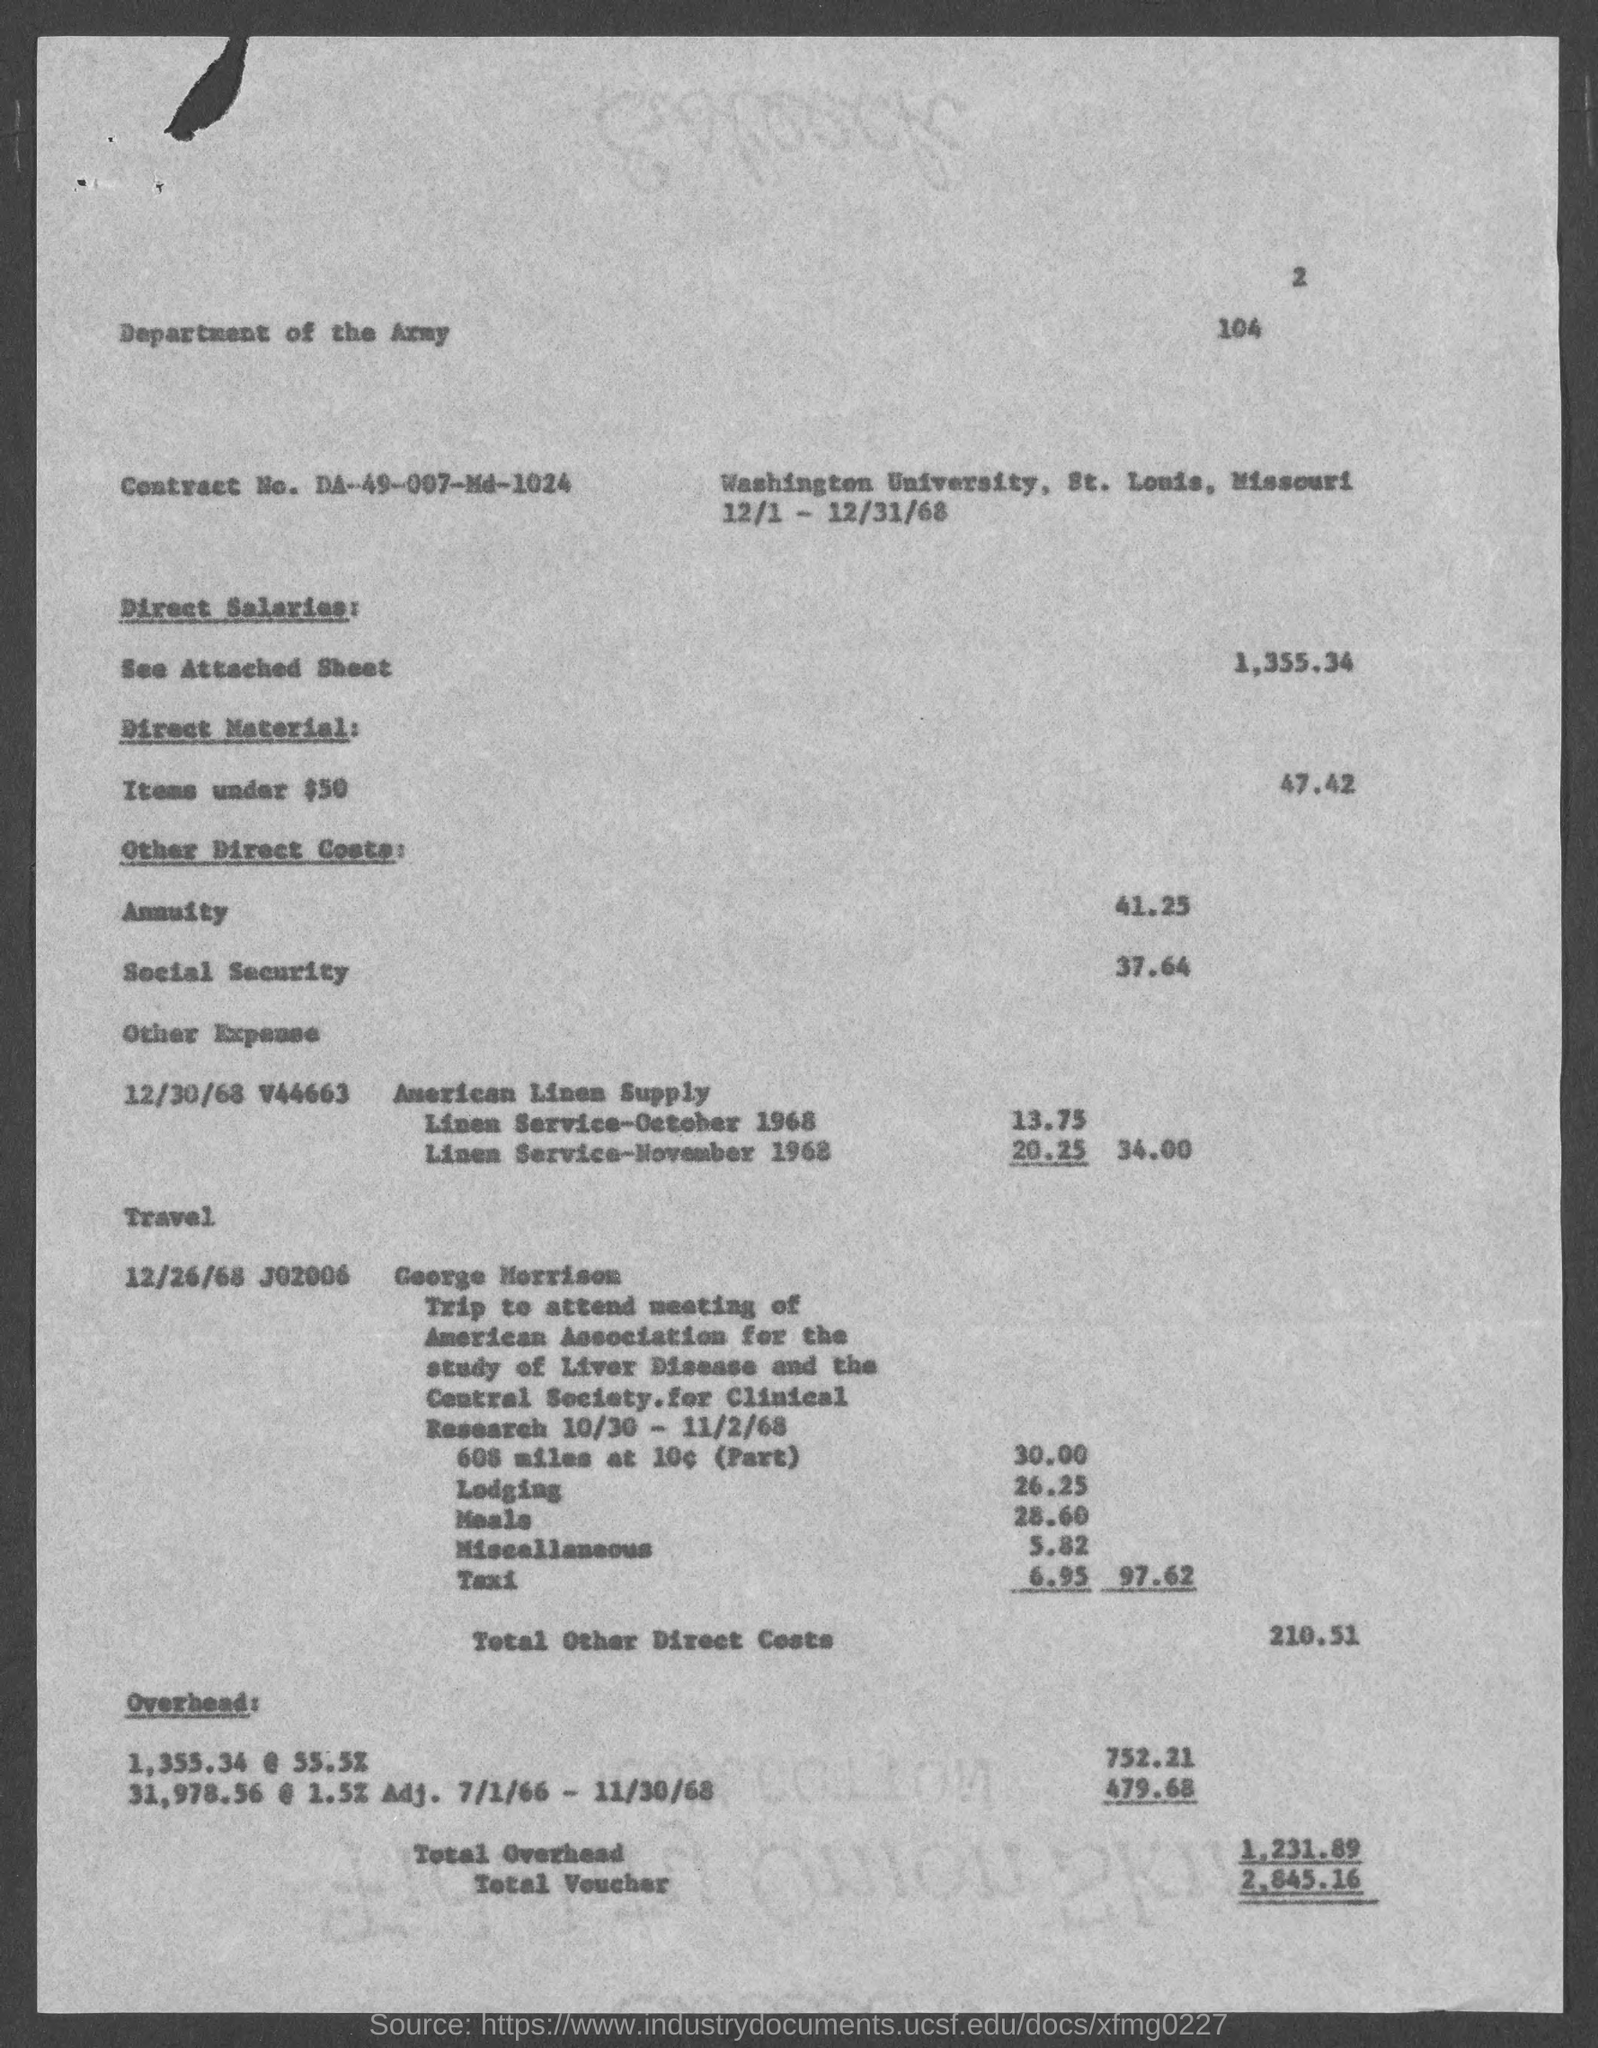What is the page number at top of the page?
Your response must be concise. 2. What is the contract no.?
Provide a succinct answer. DA-49-007-MD-1024. What is the total voucher amount ?
Keep it short and to the point. $2,845.16. What is the total other direct costs?
Give a very brief answer. $210.51. In which county is washington university  located?
Give a very brief answer. St. Louis. 